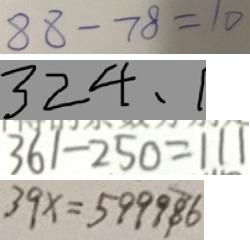Convert formula to latex. <formula><loc_0><loc_0><loc_500><loc_500>8 8 - 7 8 = 1 0 
 3 2 4 , 1 
 3 6 1 - 2 5 0 = 1 1 1 
 3 9 x = 5 9 9 9 8 6</formula> 